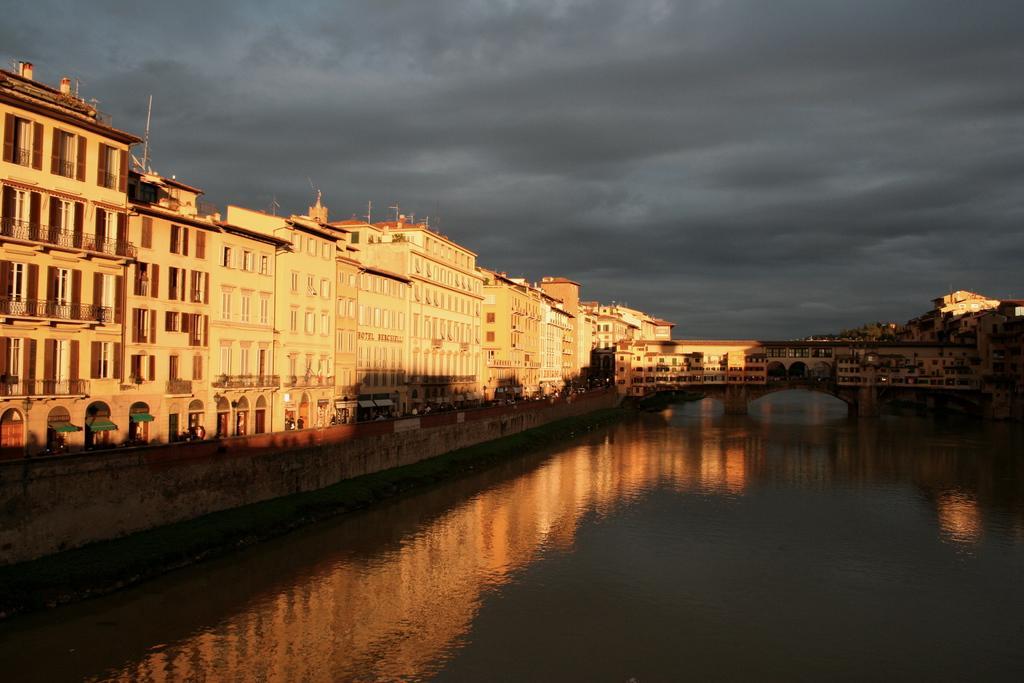Could you give a brief overview of what you see in this image? In the foreground of this image, there is water on the right. On the left and background, there are buildings. At the top, there is sky and the cloud. 